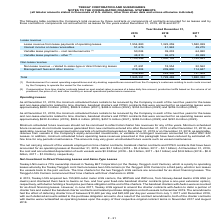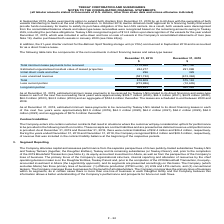According to Teekay Corporation's financial document, What was the total Total minimum lease payments to be received in 2019？ According to the financial document, 1,115,968 (in thousands). The relevant text states: "Total minimum lease payments to be received 1,115,968 897,130..." Also, As at December 31, 2019 what was the minimum lease payments to be received by Teekay LNG related to its direct financing and sales-type leases in 2020? According to the financial document, $324.7 million. The relevant text states: "xt five succeeding fiscal years were approximately $324.7 million (2020), $64.2 million (2021), $64.2 million (2022), $64.0 million (2023), $64.3 million (2024) and a..." Also, As at December 31, 2018 what was the minimum lease payments to be received by Teekay LNG related to its direct financing leases in 2019? According to the financial document, $63.9 million. The relevant text states: "in each of the next five years were approximately $63.9 million (2019), $64.3 million (2020), $64.2 million (2021), $64.2 million (2022), $64.0 million (2023) and a..." Also, can you calculate: What is the change in Total minimum lease payments to be received from December 31, 2019 to December 31, 2018? Based on the calculation: 1,115,968-897,130, the result is 218838 (in thousands). This is based on the information: "Total minimum lease payments to be received 1,115,968 897,130 l minimum lease payments to be received 1,115,968 897,130..." The key data points involved are: 1,115,968, 897,130. Also, can you calculate: What is the change in Estimated unguaranteed residual value of leased properties from December 31, 2019 to December 31, 2018? Based on the calculation: 284,277-291,098, the result is -6821 (in thousands). This is based on the information: "nteed residual value of leased properties 284,277 291,098 unguaranteed residual value of leased properties 284,277 291,098..." The key data points involved are: 284,277, 291,098. Also, can you calculate: What is the change in Initial direct costs and other from December 31, 2019 to December 31, 2018? Based on the calculation: 296-329, the result is -33 (in thousands). This is based on the information: "Initial direct costs and other 296 329 Initial direct costs and other 296 329..." The key data points involved are: 296, 329. 